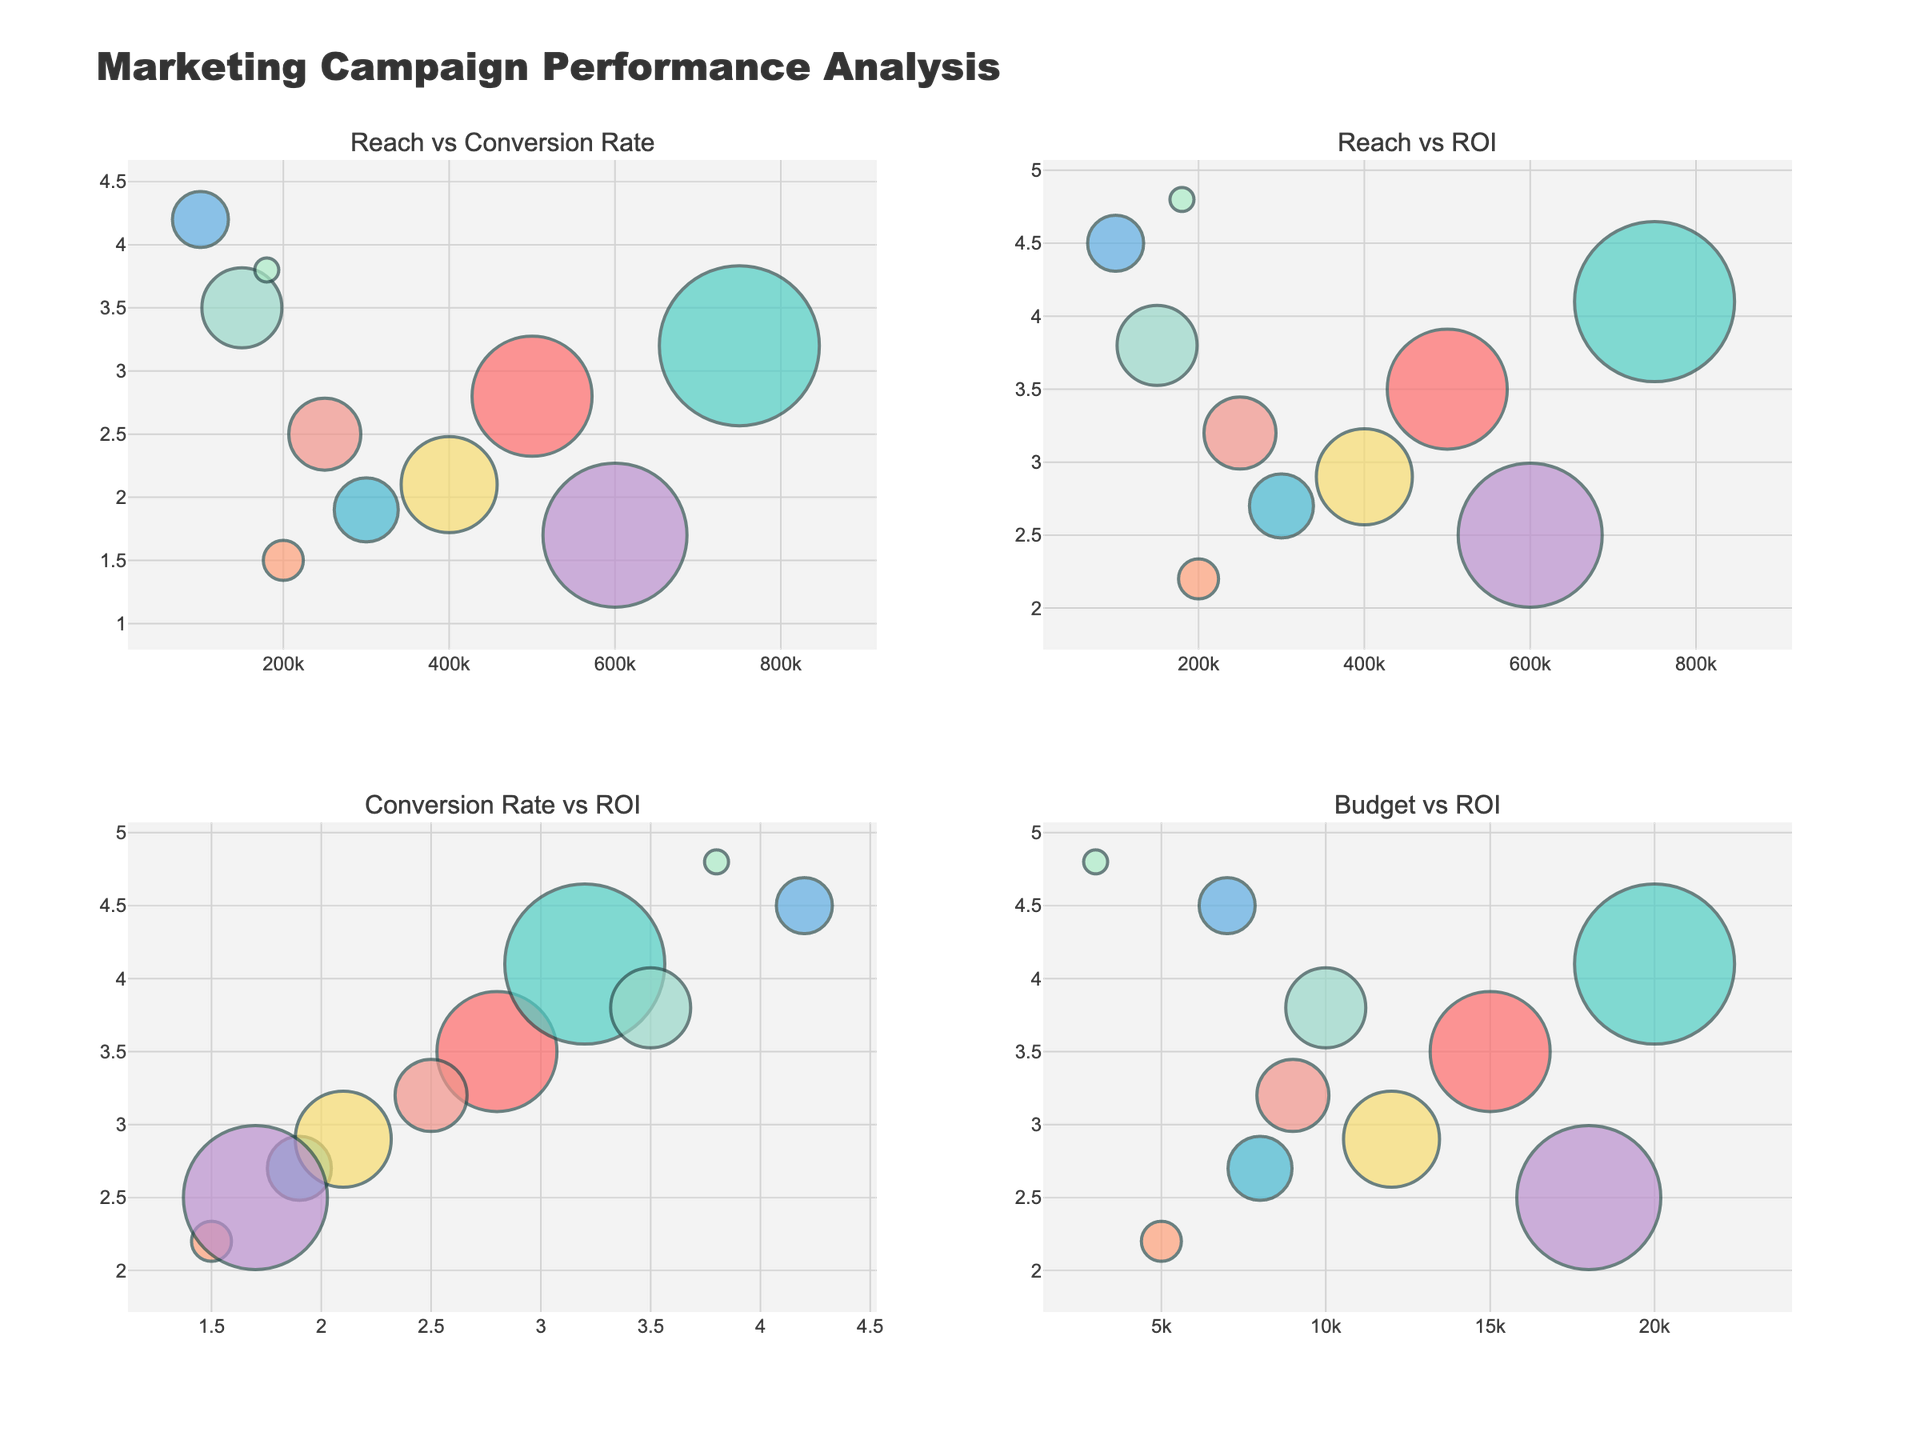What is the title of the figure? The title of the figure is present at the top of the visual where the main heading is provided.
Answer: Marketing Campaign Performance Analysis Which channel has the highest conversion rate? To find the highest conversion rate, look for the data point with the highest y-value in the subplot titled "Reach vs Conversion Rate" or "Conversion Rate vs ROI". The highest y-value in both of these subplots is around 4.2.
Answer: App Store Search Ads Which subplot compares Reach to ROI? There are four subplots, each with different axes titles. The one with "Reach" on the x-axis and "ROI" on the y-axis is the subplot of interest.
Answer: The top-right subplot How can you differentiate channels in the figure? Channels can be differentiated by the color of the bubbles and their associated hovertext when you hover over each bubble.
Answer: By bubble color and hovertext What is the ROI for TikTok Ads? Locate TikTok Ads in any subplot involving ROI, then look at the corresponding y-value.
Answer: 2.9 Which channel has the smallest budget and what is its ROI? Look for the smallest bubbles (indicating the smallest budgets) and identify the corresponding ROI in any subplot involving ROI. The smallest bubble is associated with the budget of 3000.
Answer: Email Marketing with an ROI of 4.8 Among Facebook Ads and Google AdWords, which has a better conversion rate? Compare the y-values for Facebook Ads and Google AdWords in the subplot "Reach vs Conversion Rate". Google AdWords has a conversion rate of 3.2, higher than Facebook Ads at 2.8.
Answer: Google AdWords What is the average ROI of all campaigns? Sum all ROIs and divide by the number of campaigns (10). (3.5 + 4.1 + 2.7 + 2.2 + 3.8 + 2.9 + 2.5 + 4.5 + 3.2 + 4.8) / 10 = 3.42
Answer: 3.42 Which subplot compares Budget to ROI? There are four subplots, and we need to find the one with "Campaign Budget" on the x-axis and "ROI" on the y-axis.
Answer: Bottom-right subplot What is the relationship between Budget and Reach? Observe the size of the bubbles in the subplot "Reach vs Conversion Rate" or "Reach vs ROI", large bubbles indicate larger budgets and larger reaches. Generally, bigger budget campaigns have larger reaches.
Answer: Larger budgets tend to have larger reaches 